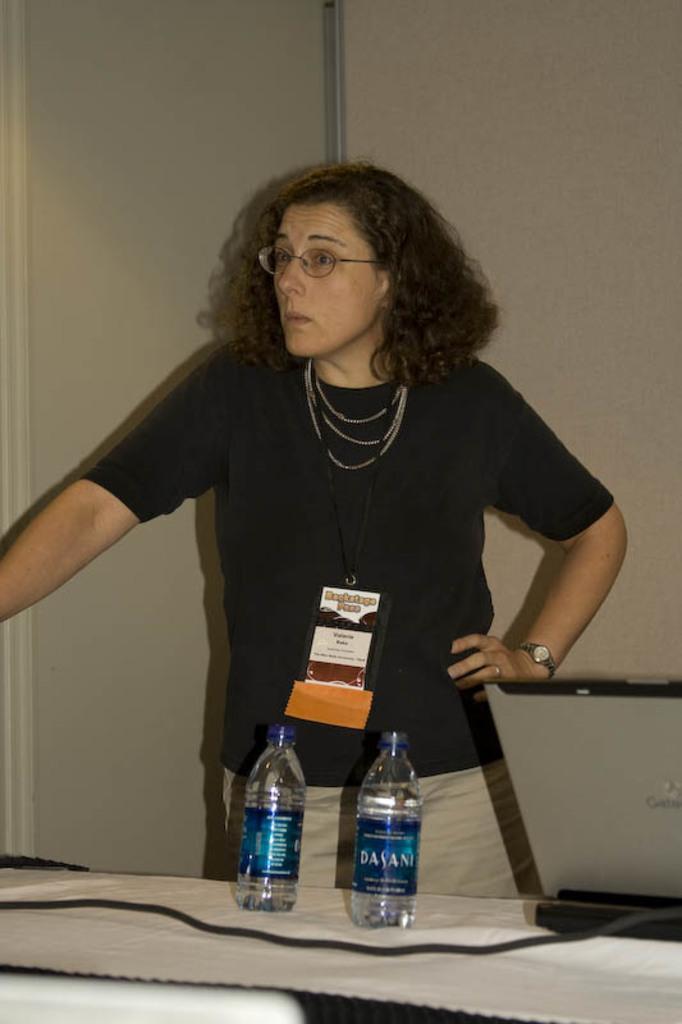In one or two sentences, can you explain what this image depicts? A lady wearing specs, chains, and also a watch is standing. In front of her there is a table. On the table there is a wire and two bottles. In the background there is wall. 